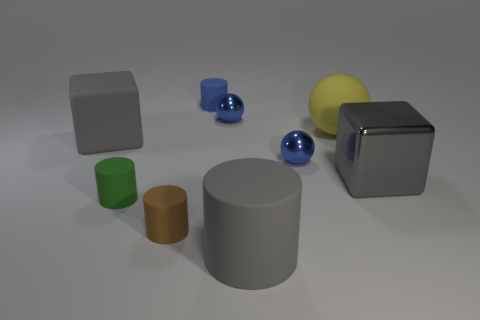What shapes and colors can you identify in this image? In the image, I can identify several shapes including a large gray cylinder, a small blue cylinder, two spheres - one blue and one yellow, and two cubes - one gray and one white. The colors present are gray, blue, yellow, white, green, and brown. 